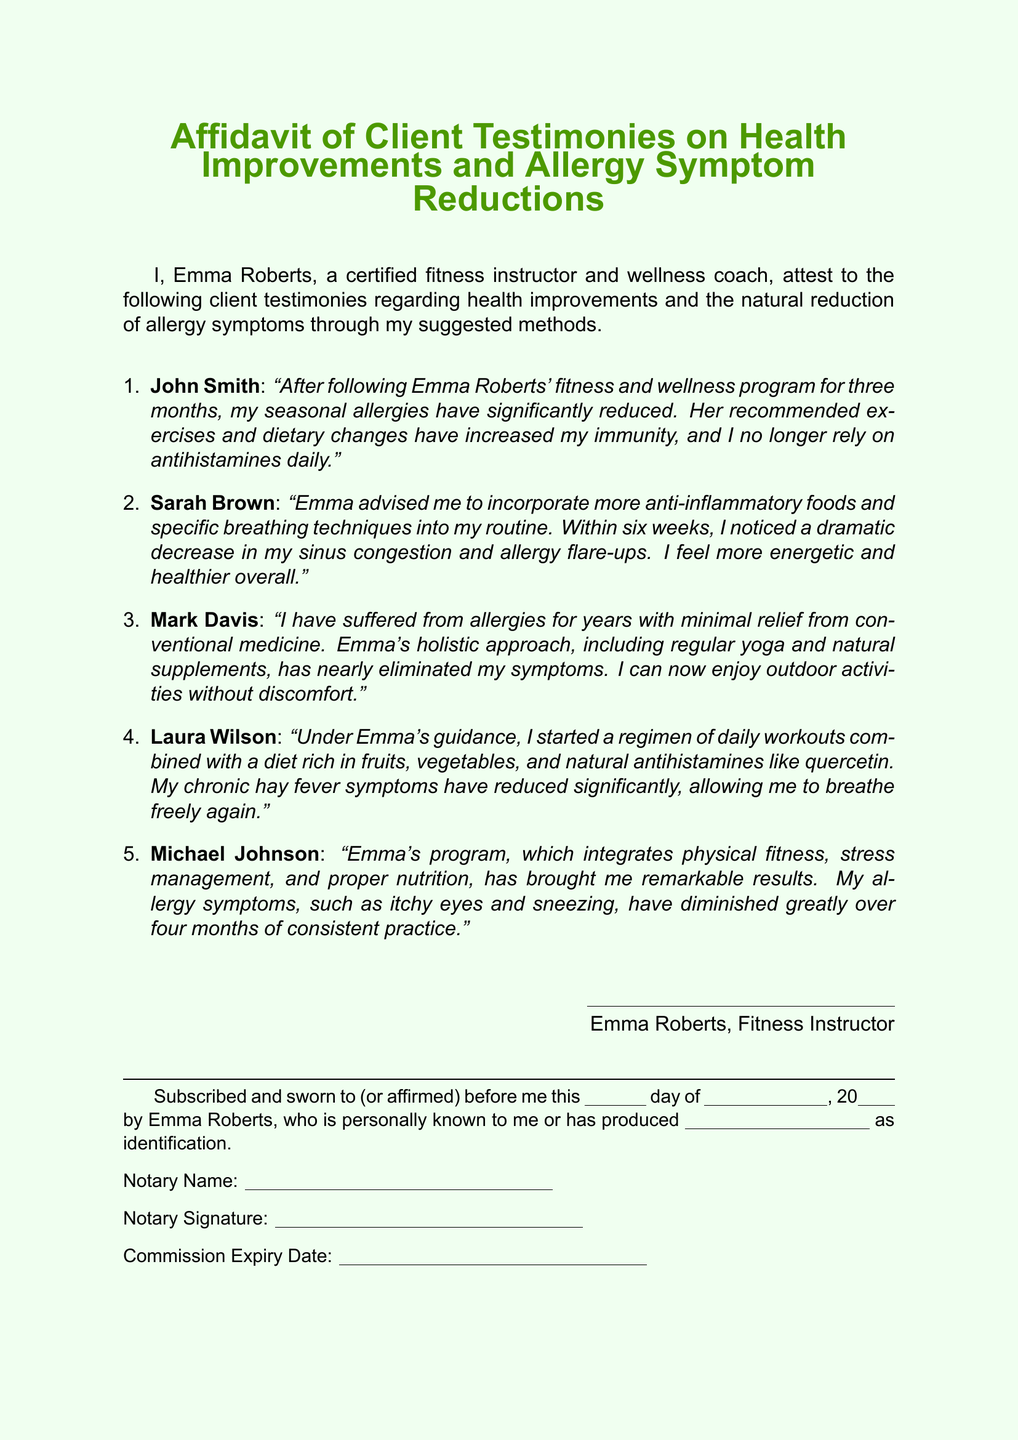What is the name of the fitness instructor? The fitness instructor's name is mentioned in the opening statement of the affidavit.
Answer: Emma Roberts How many client testimonies are included? The number of testimonials is represented by the items in the enumerated list.
Answer: Five What types of foods did Sarah Brown incorporate into her routine? The affidavit mentions specific dietary changes that Sarah Brown made.
Answer: Anti-inflammatory foods Which client reported a nearly complete elimination of their allergy symptoms? This information can be found in Mark Davis's personal testimony.
Answer: Mark Davis What method did Michael Johnson refer to in his testimony? The affidavit indicates the overall approach utilized by Michael Johnson for his health improvements.
Answer: Integrates physical fitness, stress management, and proper nutrition What is the date format for the subscription in this document? The document specifies how the date is to be filled out during the notarization process.
Answer: Day of month, year Who signed the affidavit? The signatory of the affidavit is specified in the document.
Answer: Emma Roberts What is the name of one natural antihistamine mentioned? The document references dietary elements that serve as natural antihistamines.
Answer: Quercetin 